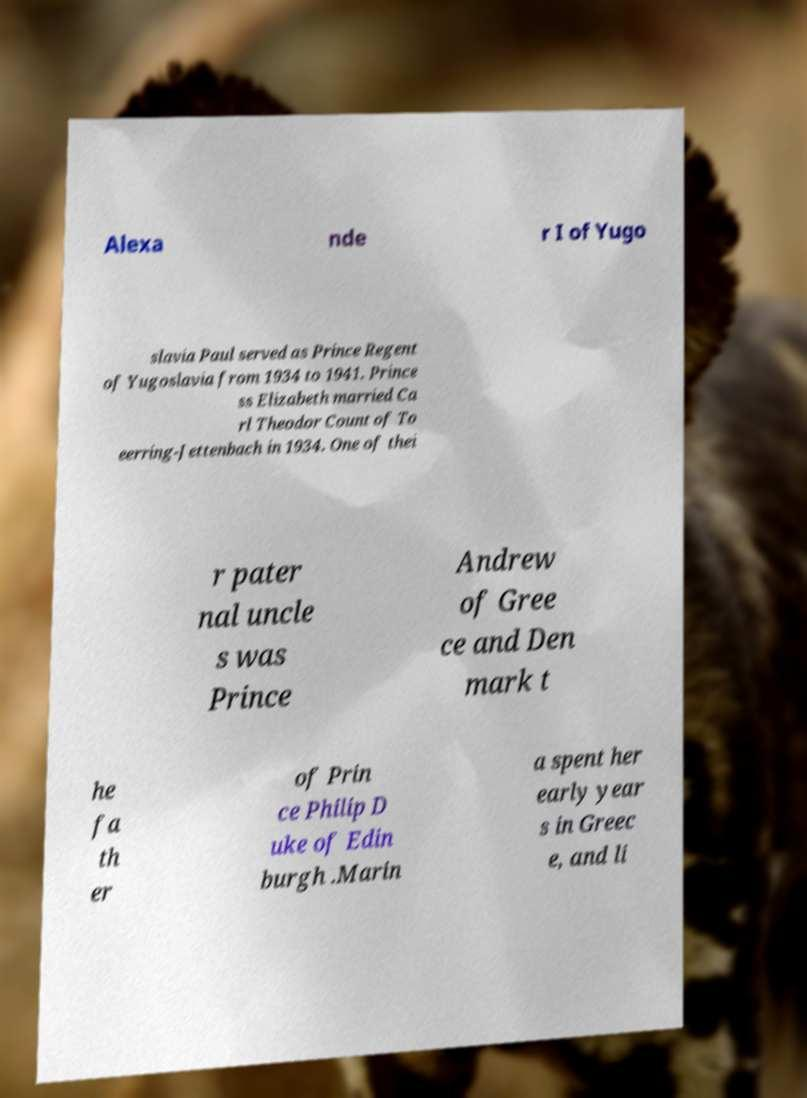There's text embedded in this image that I need extracted. Can you transcribe it verbatim? Alexa nde r I of Yugo slavia Paul served as Prince Regent of Yugoslavia from 1934 to 1941. Prince ss Elizabeth married Ca rl Theodor Count of To eerring-Jettenbach in 1934. One of thei r pater nal uncle s was Prince Andrew of Gree ce and Den mark t he fa th er of Prin ce Philip D uke of Edin burgh .Marin a spent her early year s in Greec e, and li 